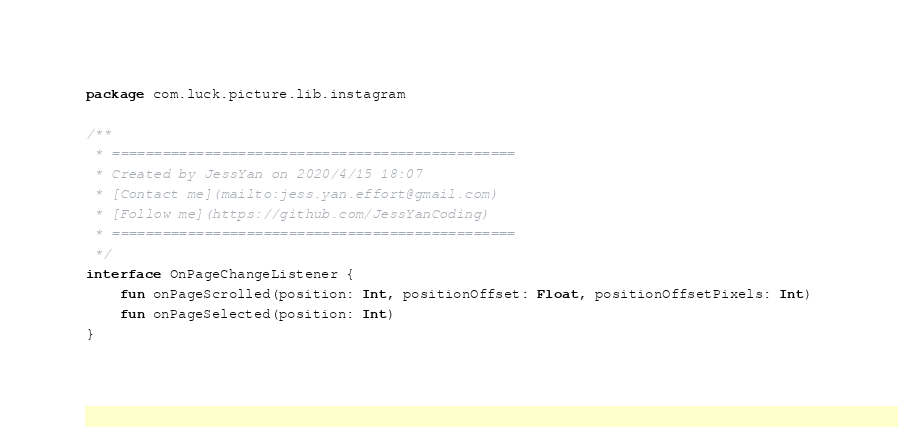Convert code to text. <code><loc_0><loc_0><loc_500><loc_500><_Kotlin_>package com.luck.picture.lib.instagram

/**
 * ================================================
 * Created by JessYan on 2020/4/15 18:07
 * [Contact me](mailto:jess.yan.effort@gmail.com)
 * [Follow me](https://github.com/JessYanCoding)
 * ================================================
 */
interface OnPageChangeListener {
    fun onPageScrolled(position: Int, positionOffset: Float, positionOffsetPixels: Int)
    fun onPageSelected(position: Int)
}</code> 